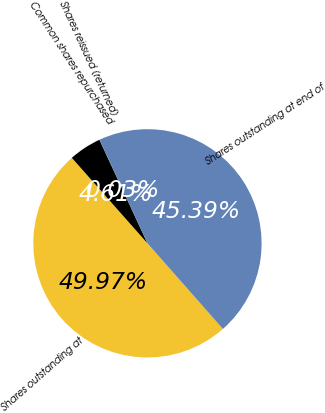Convert chart to OTSL. <chart><loc_0><loc_0><loc_500><loc_500><pie_chart><fcel>Shares outstanding at<fcel>Common shares repurchased<fcel>Shares reissued (returned)<fcel>Shares outstanding at end of<nl><fcel>49.97%<fcel>4.61%<fcel>0.03%<fcel>45.39%<nl></chart> 